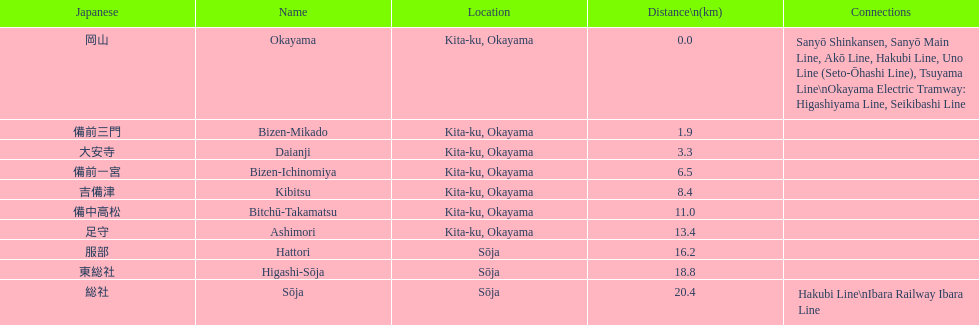Which has the most distance, hattori or kibitsu? Hattori. 